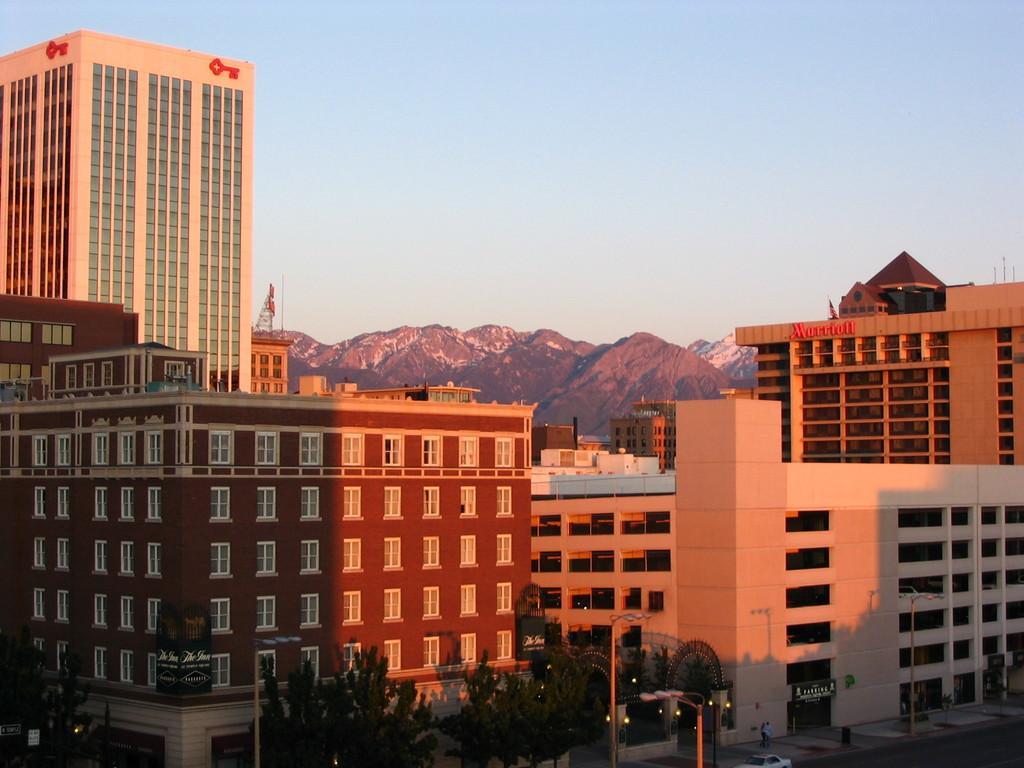How would you summarize this image in a sentence or two? In this picture I can see buildings, trees and few poles and I can see text on the building and I can see hills in the back and I can see blue sky and I can see a car and looks like a human on the sidewalk. 